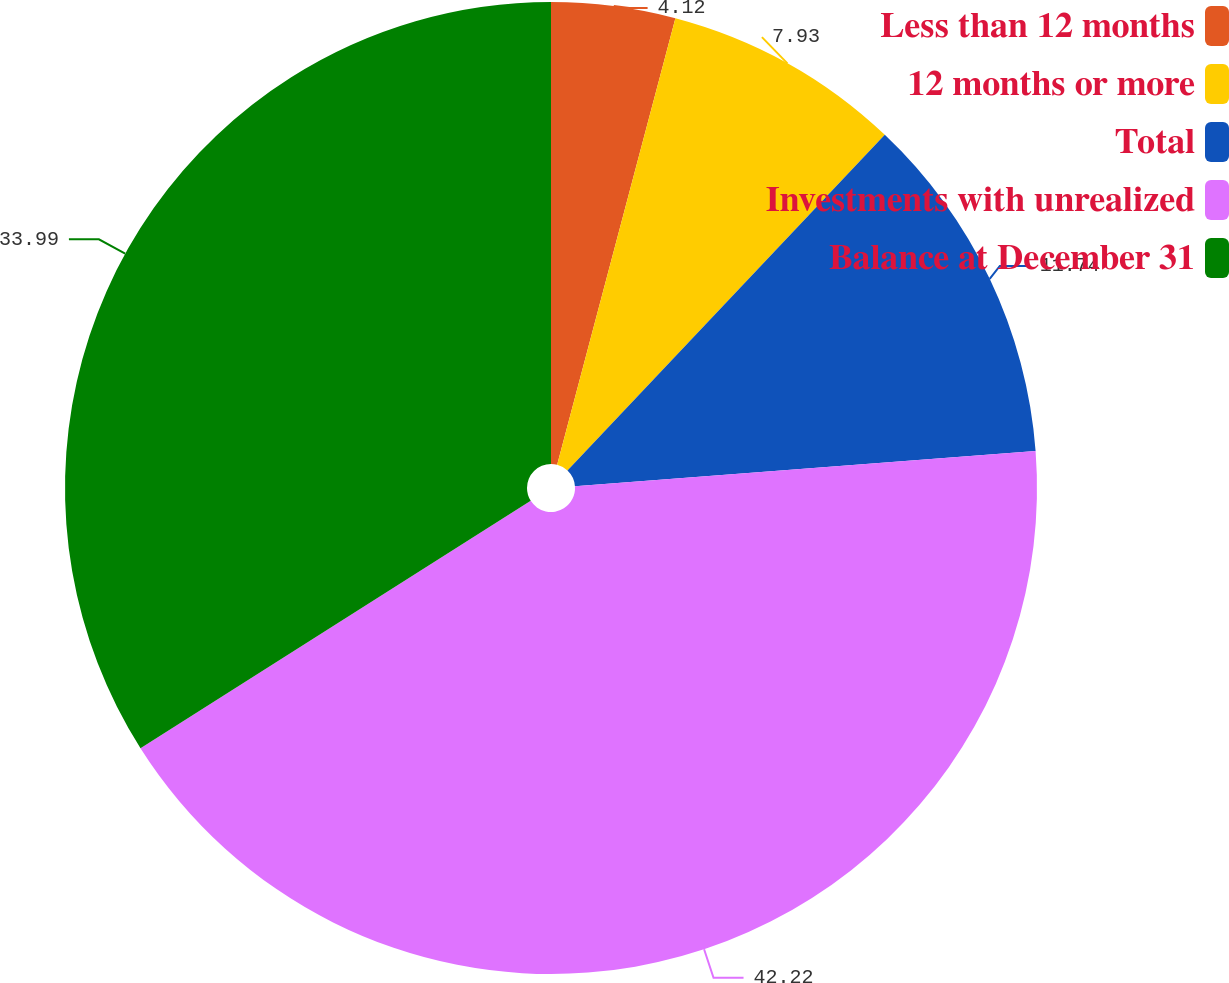Convert chart. <chart><loc_0><loc_0><loc_500><loc_500><pie_chart><fcel>Less than 12 months<fcel>12 months or more<fcel>Total<fcel>Investments with unrealized<fcel>Balance at December 31<nl><fcel>4.12%<fcel>7.93%<fcel>11.74%<fcel>42.22%<fcel>33.99%<nl></chart> 